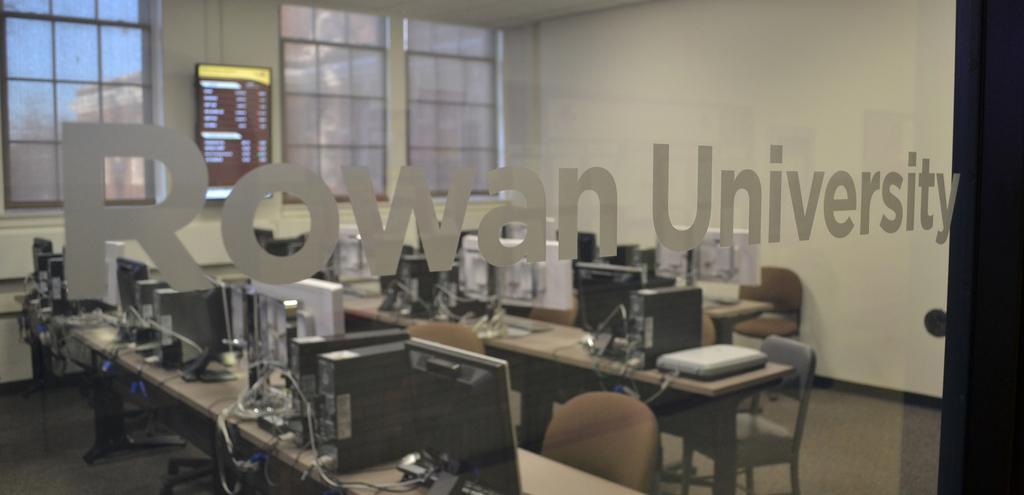Please provide a concise description of this image. This image is taken indoors. In the middle of the image there is a glass door with a text on it. Through the glass door, we can see there are a few tables with monitors, CPUs and many things on them. There are a few empty chairs on the floor. In the background there is a wall with windows and there is a television on the wall. At the top of the image there is a ceiling. 